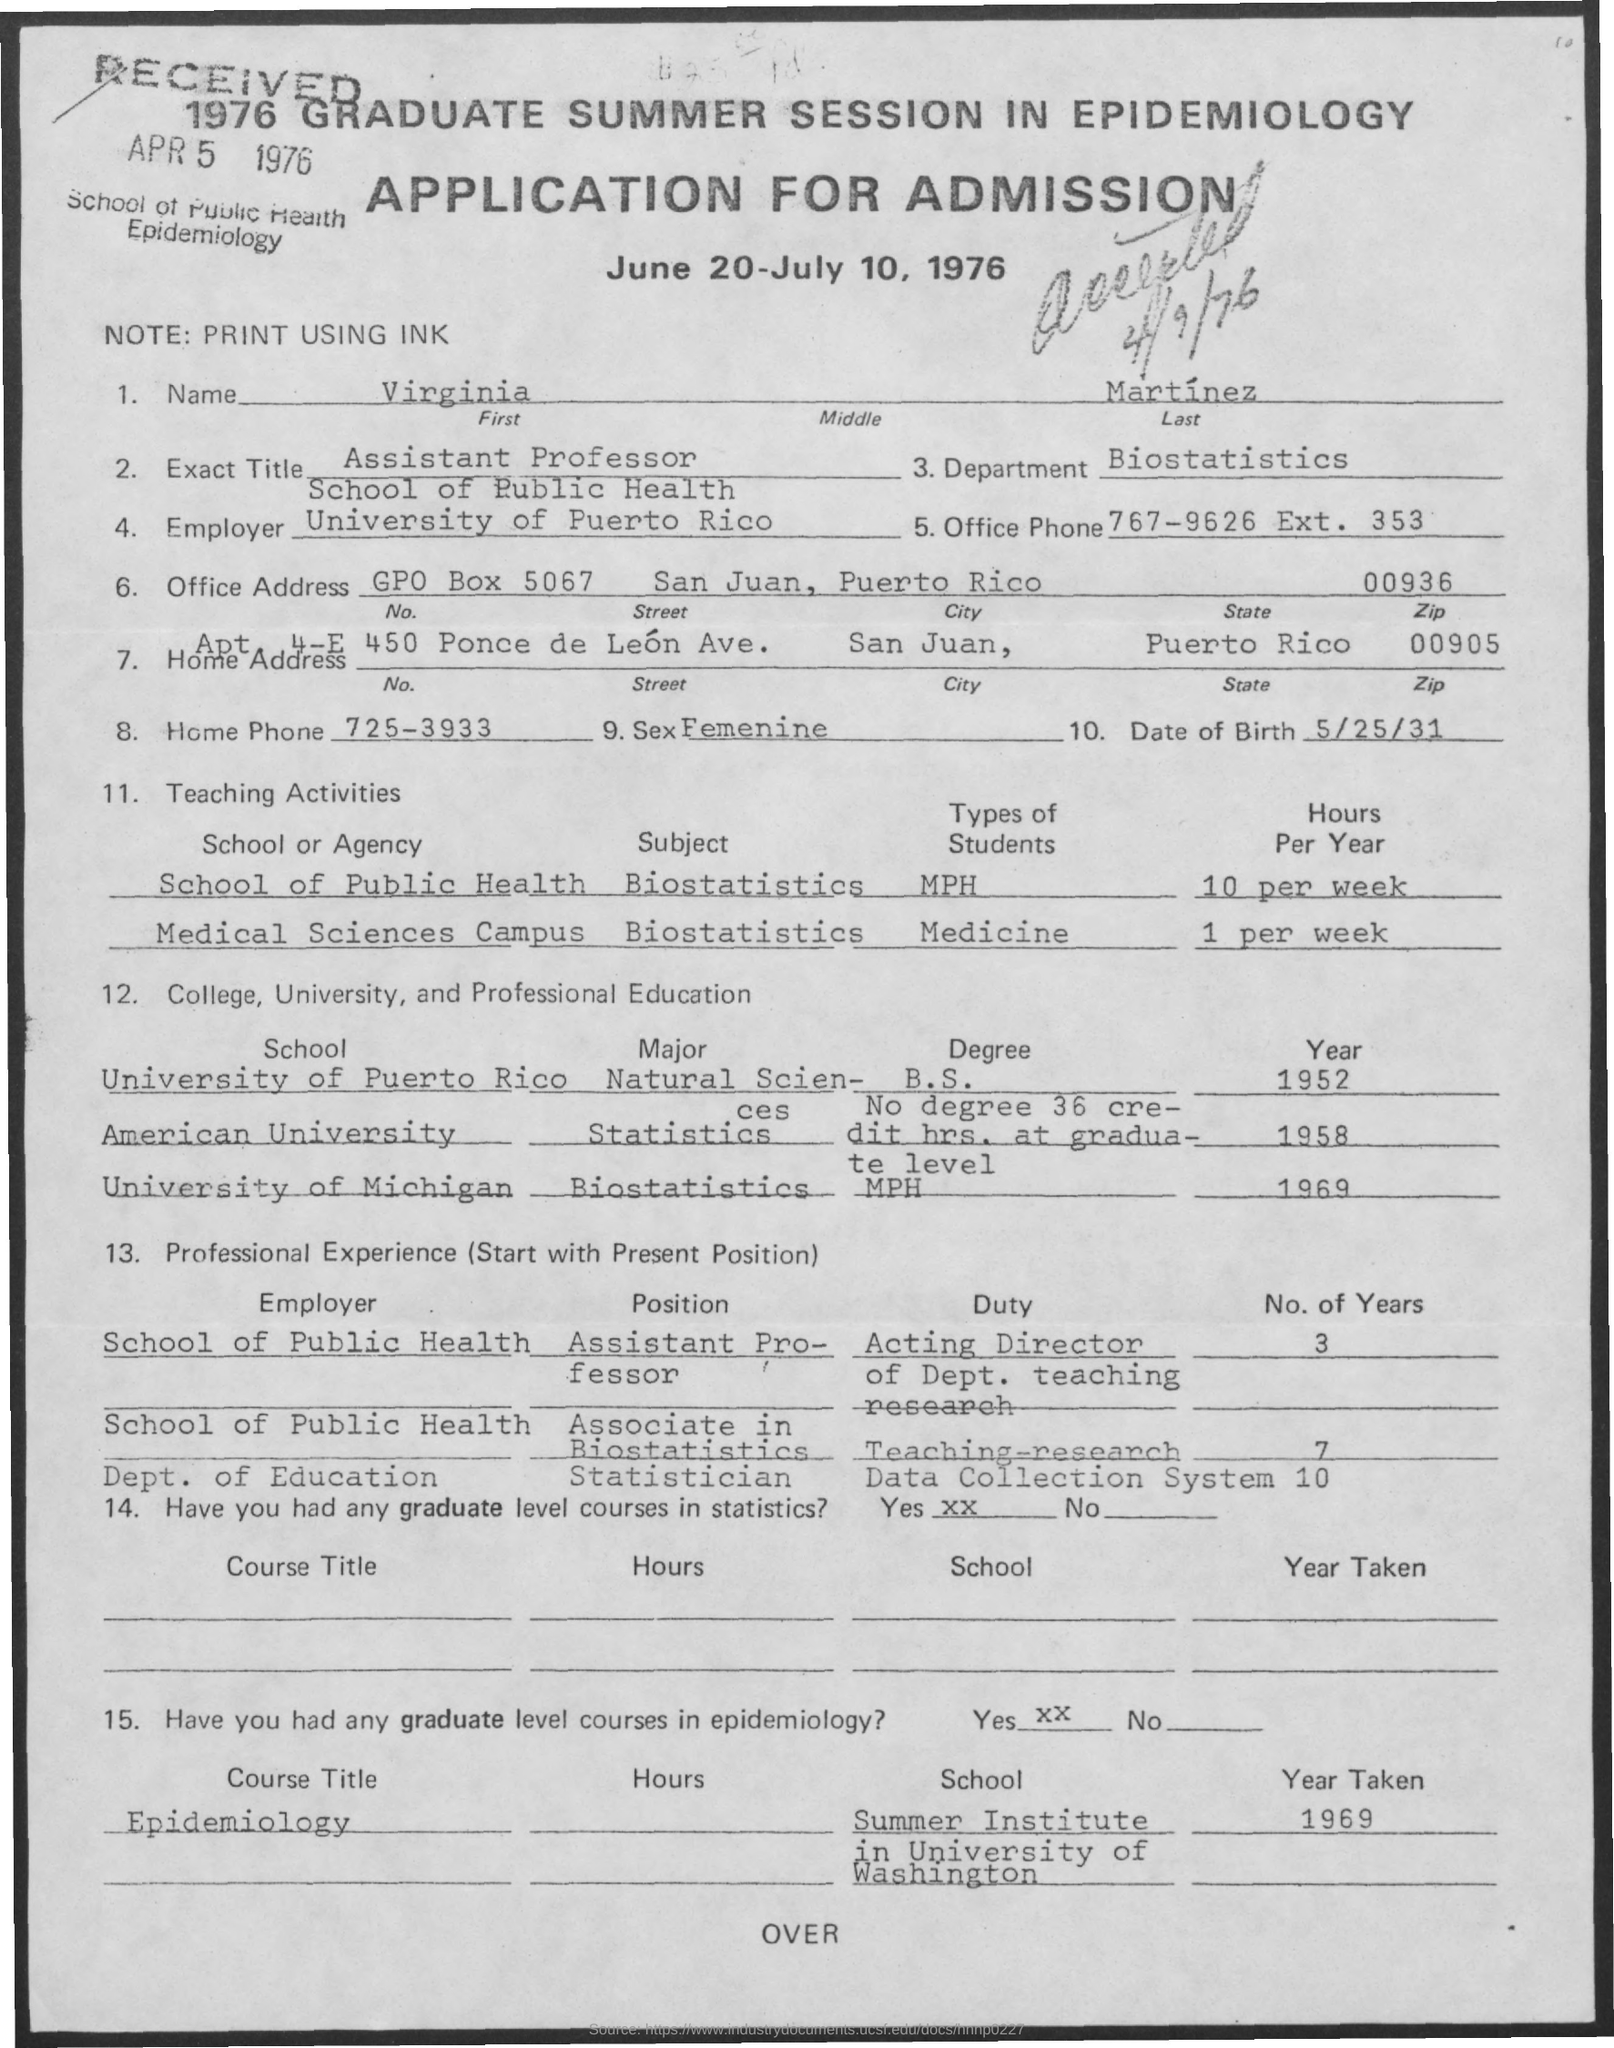What is the Title of the document?
Offer a terse response. APPLICATION FOR ADMISSION. What is the First Name?
Provide a short and direct response. Virginia. What is the Last Name?
Offer a terse response. Martinez. What is the Exact Title?
Offer a terse response. Assistant Professor. What is the Department?
Offer a terse response. Biostatistics. What is the Office Phone?
Provide a succinct answer. 767-9626 Ext. 353. What is the Date of Birth?
Offer a terse response. 5/25/31. What is the City?
Ensure brevity in your answer.  San Juan. What is the State?
Ensure brevity in your answer.  Puerto Rico. 